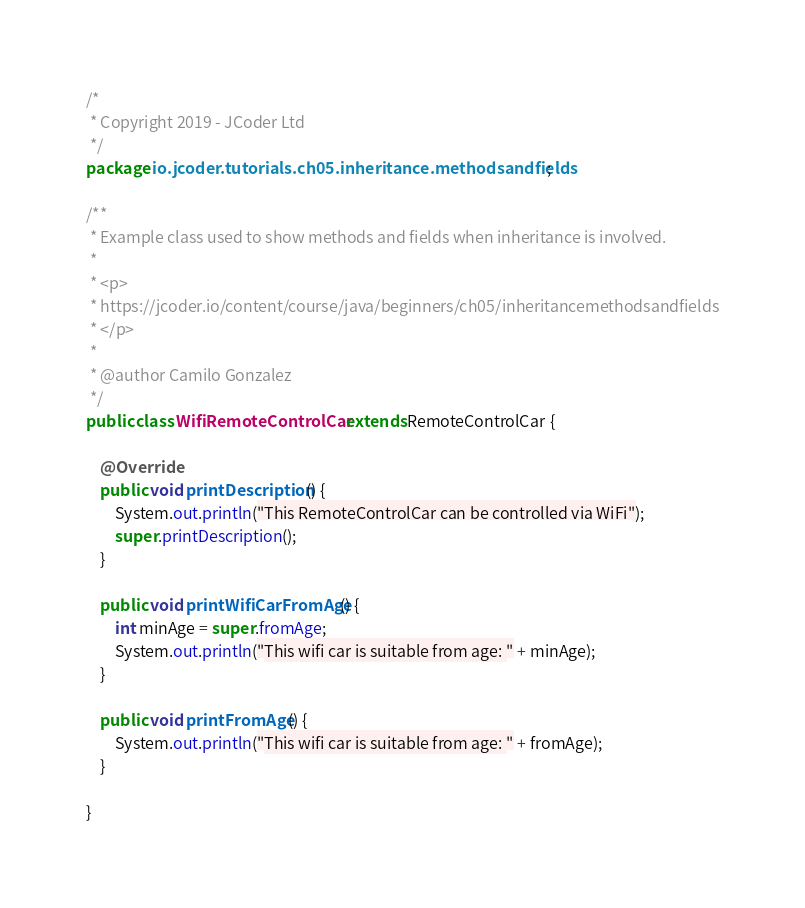<code> <loc_0><loc_0><loc_500><loc_500><_Java_>/*
 * Copyright 2019 - JCoder Ltd
 */
package io.jcoder.tutorials.ch05.inheritance.methodsandfields;

/**
 * Example class used to show methods and fields when inheritance is involved.
 * 
 * <p>
 * https://jcoder.io/content/course/java/beginners/ch05/inheritancemethodsandfields
 * </p>
 * 
 * @author Camilo Gonzalez
 */
public class WifiRemoteControlCar extends RemoteControlCar {

    @Override
    public void printDescription() {
        System.out.println("This RemoteControlCar can be controlled via WiFi");
        super.printDescription();
    }
    
    public void printWifiCarFromAge() {
        int minAge = super.fromAge;
        System.out.println("This wifi car is suitable from age: " + minAge);
    }
    
    public void printFromAge() {
        System.out.println("This wifi car is suitable from age: " + fromAge);
    }

}
</code> 